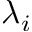<formula> <loc_0><loc_0><loc_500><loc_500>\lambda _ { i }</formula> 